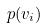<formula> <loc_0><loc_0><loc_500><loc_500>p ( v _ { i } )</formula> 